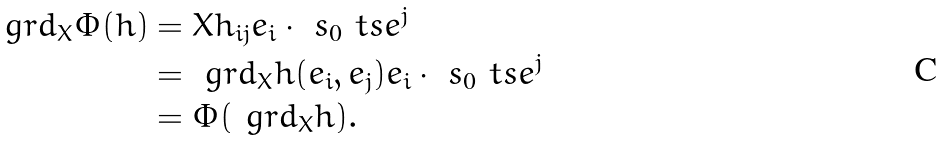<formula> <loc_0><loc_0><loc_500><loc_500>\ g r d _ { X } \Phi ( h ) & = X h _ { i j } e _ { i } \cdot \ s _ { 0 } \ t s e ^ { j } \\ & = \ g r d _ { X } h ( e _ { i } , e _ { j } ) e _ { i } \cdot \ s _ { 0 } \ t s e ^ { j } \\ & = \Phi ( \ g r d _ { X } h ) .</formula> 